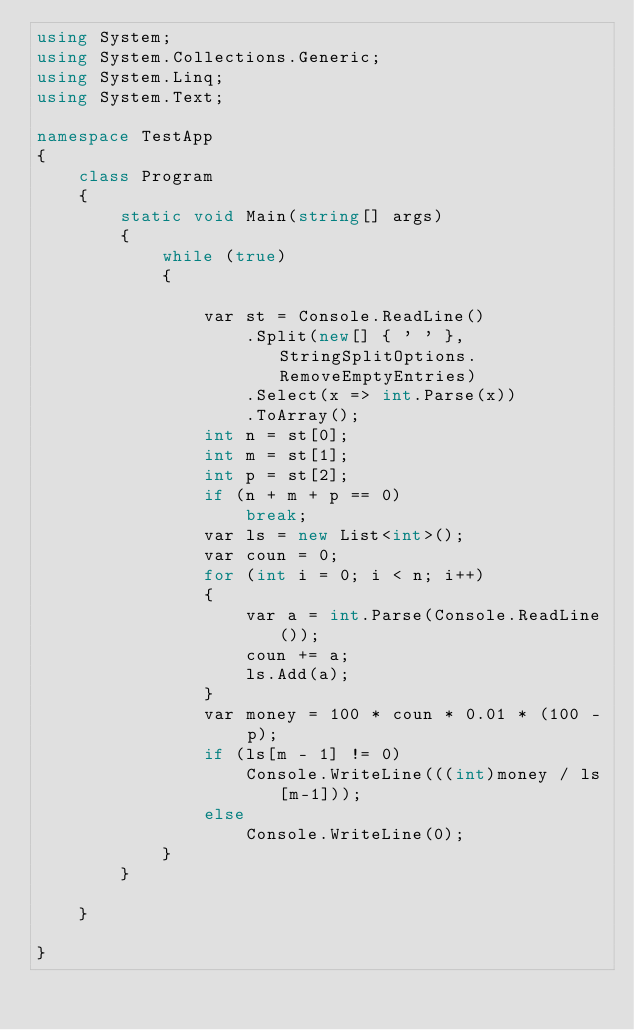<code> <loc_0><loc_0><loc_500><loc_500><_C#_>using System;
using System.Collections.Generic;
using System.Linq;
using System.Text;
 
namespace TestApp
{
    class Program
    {
        static void Main(string[] args)
        {
            while (true)
            {
                 
                var st = Console.ReadLine()
                    .Split(new[] { ' ' }, StringSplitOptions.RemoveEmptyEntries)
                    .Select(x => int.Parse(x))
                    .ToArray();
                int n = st[0];
                int m = st[1];
                int p = st[2];
                if (n + m + p == 0)
                    break;
                var ls = new List<int>();
                var coun = 0;
                for (int i = 0; i < n; i++)
                {
                    var a = int.Parse(Console.ReadLine());
                    coun += a;
                    ls.Add(a);
                }
                var money = 100 * coun * 0.01 * (100 - p);
                if (ls[m - 1] != 0)
                    Console.WriteLine(((int)money / ls[m-1]));
                else
                    Console.WriteLine(0);
            }
        }
         
    }
 
}
</code> 